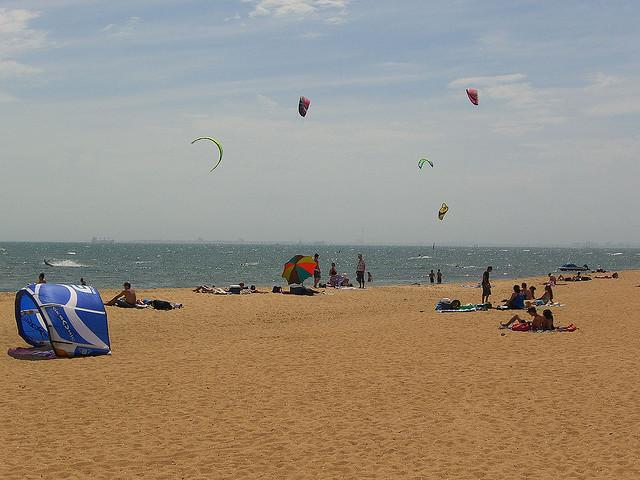What caused all the indents in the sand? footprints 